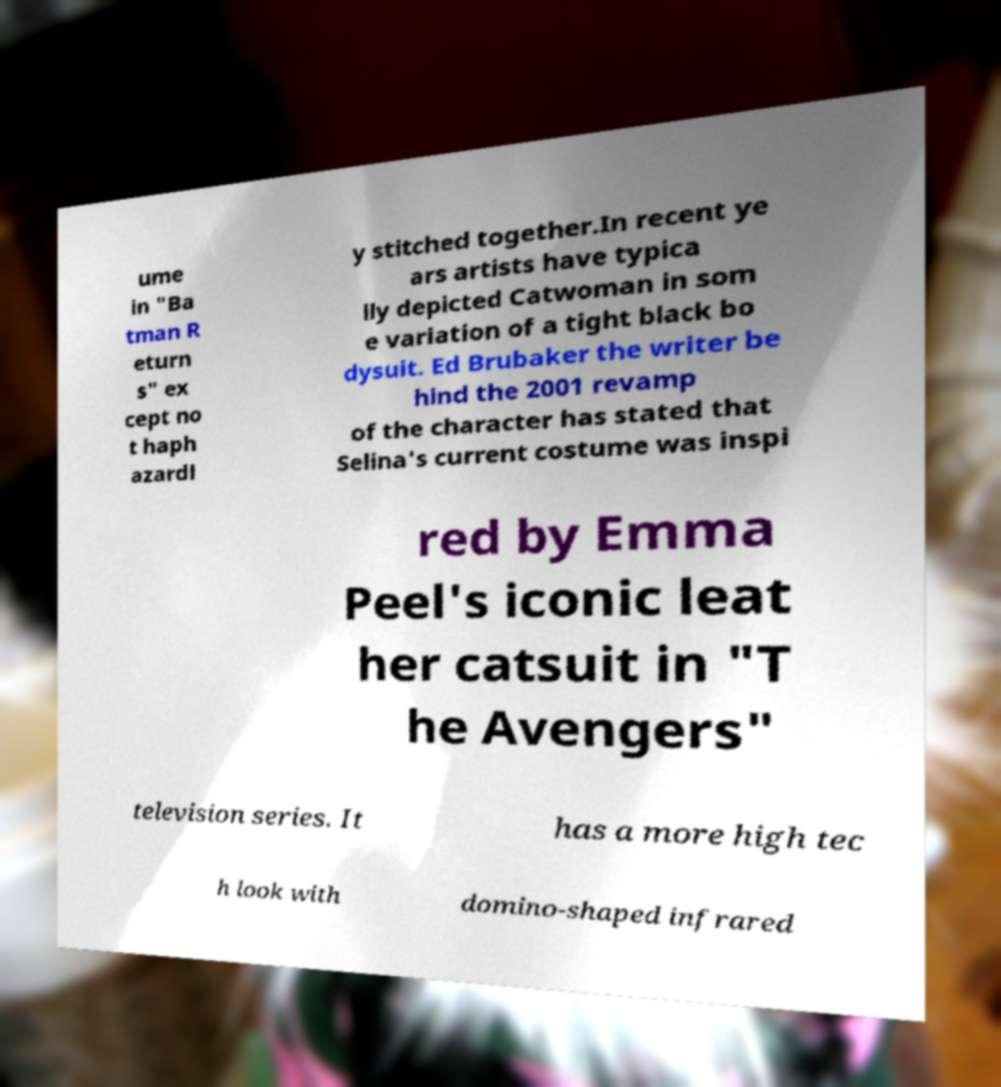For documentation purposes, I need the text within this image transcribed. Could you provide that? ume in "Ba tman R eturn s" ex cept no t haph azardl y stitched together.In recent ye ars artists have typica lly depicted Catwoman in som e variation of a tight black bo dysuit. Ed Brubaker the writer be hind the 2001 revamp of the character has stated that Selina's current costume was inspi red by Emma Peel's iconic leat her catsuit in "T he Avengers" television series. It has a more high tec h look with domino-shaped infrared 